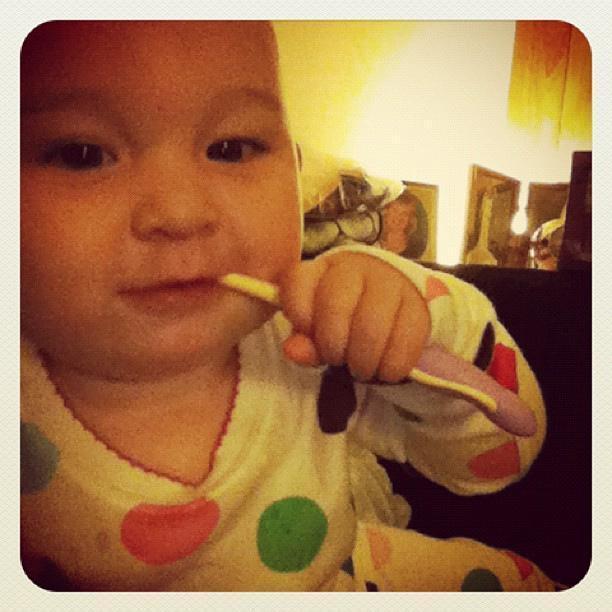How many toothbrushes are there?
Give a very brief answer. 1. How many rolling suitcases are visible?
Give a very brief answer. 0. 